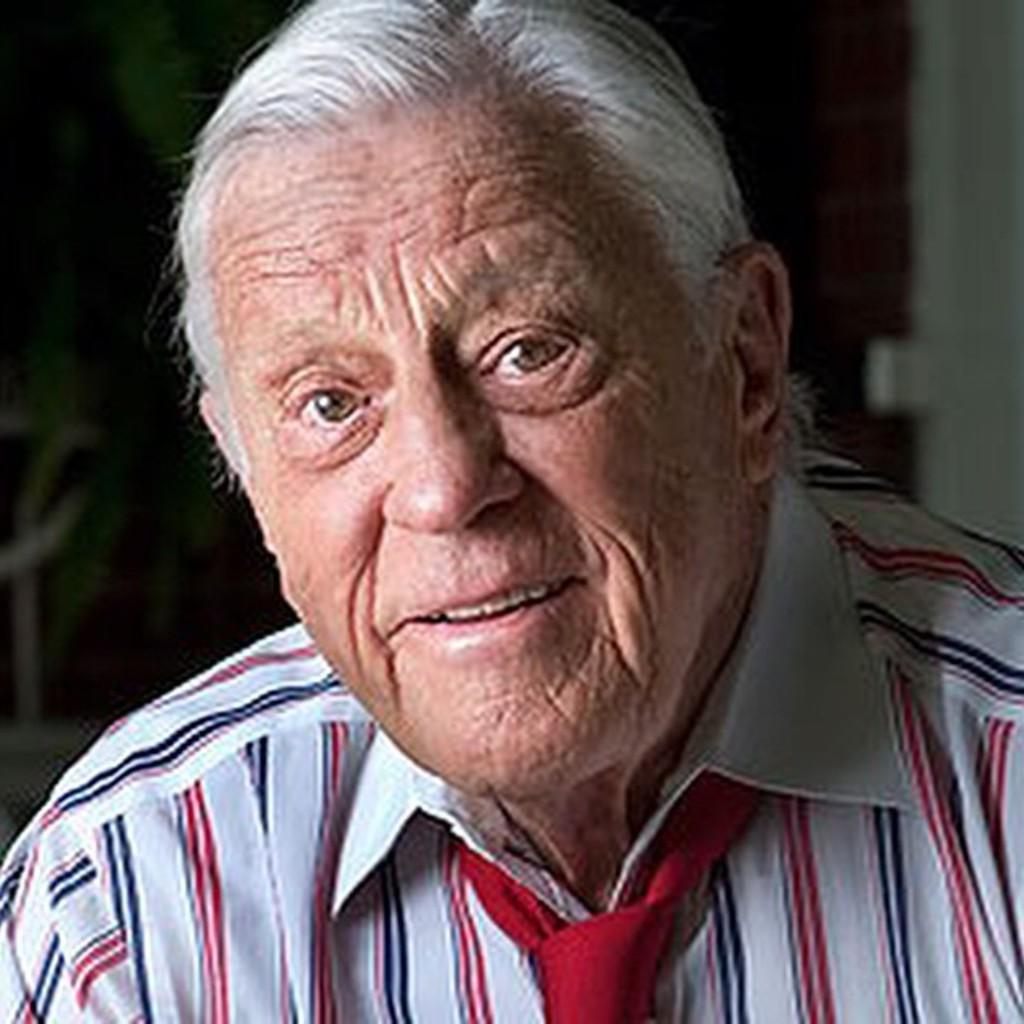What is the main subject of the picture? The main subject of the picture is an old man. Can you describe the old man's clothing? The old man is wearing a white shirt with a red color strip and a red tie. What is the old man doing in the picture? The old man is smiling and giving a pose into the camera. How is the background of the image depicted? The background of the image is blurred. What type of creature is jumping in the background of the image? There is no creature jumping in the background of the image; the background is blurred. What sense is the old man using to interact with the camera? The old man is using his sense of sight to interact with the camera, as he is posing and smiling for the picture. 